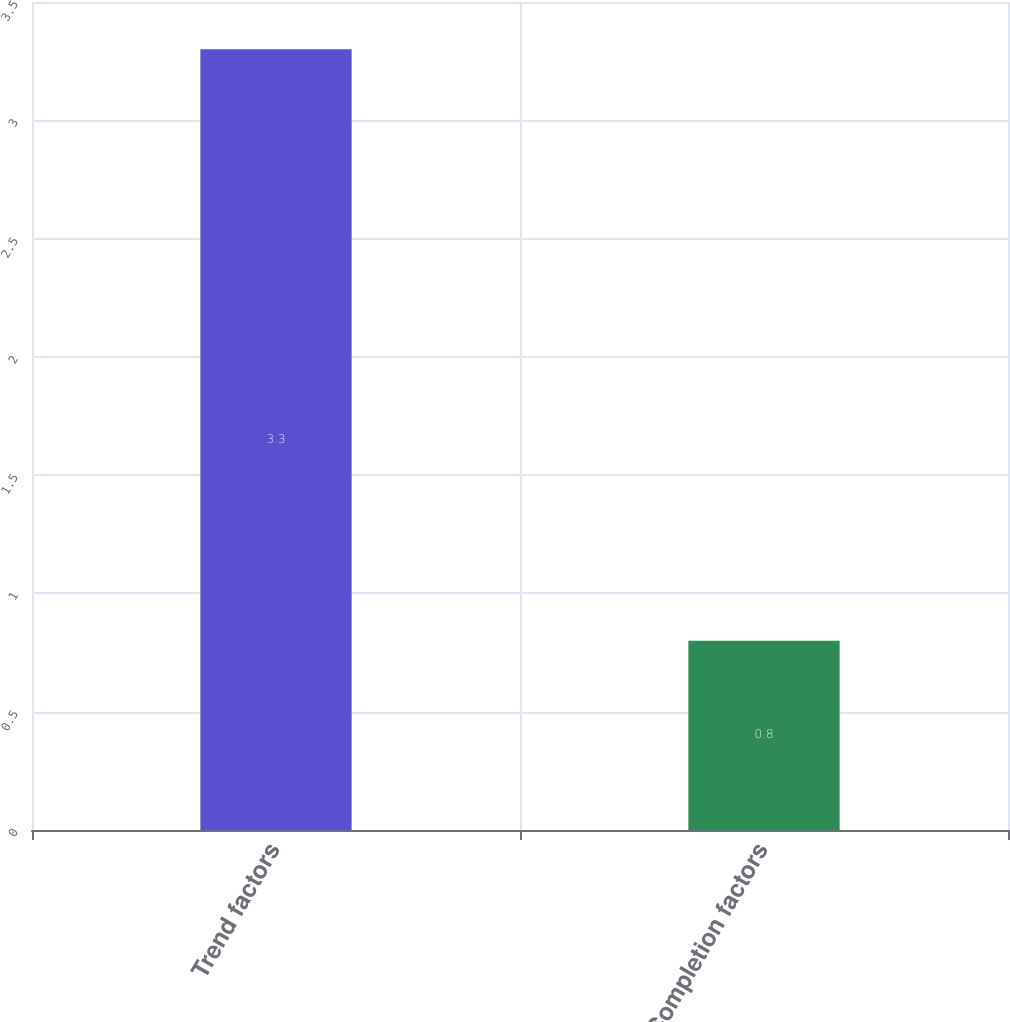<chart> <loc_0><loc_0><loc_500><loc_500><bar_chart><fcel>Trend factors<fcel>Completion factors<nl><fcel>3.3<fcel>0.8<nl></chart> 